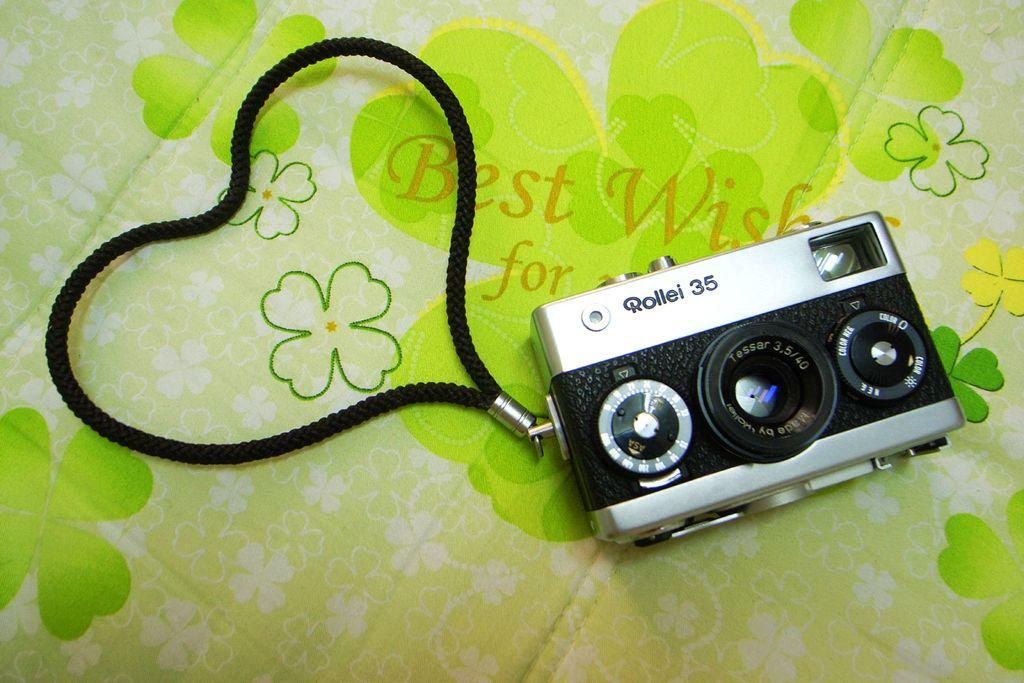Provide a one-sentence caption for the provided image. Rollei 35 camera that is black and silver with a black string attached. 